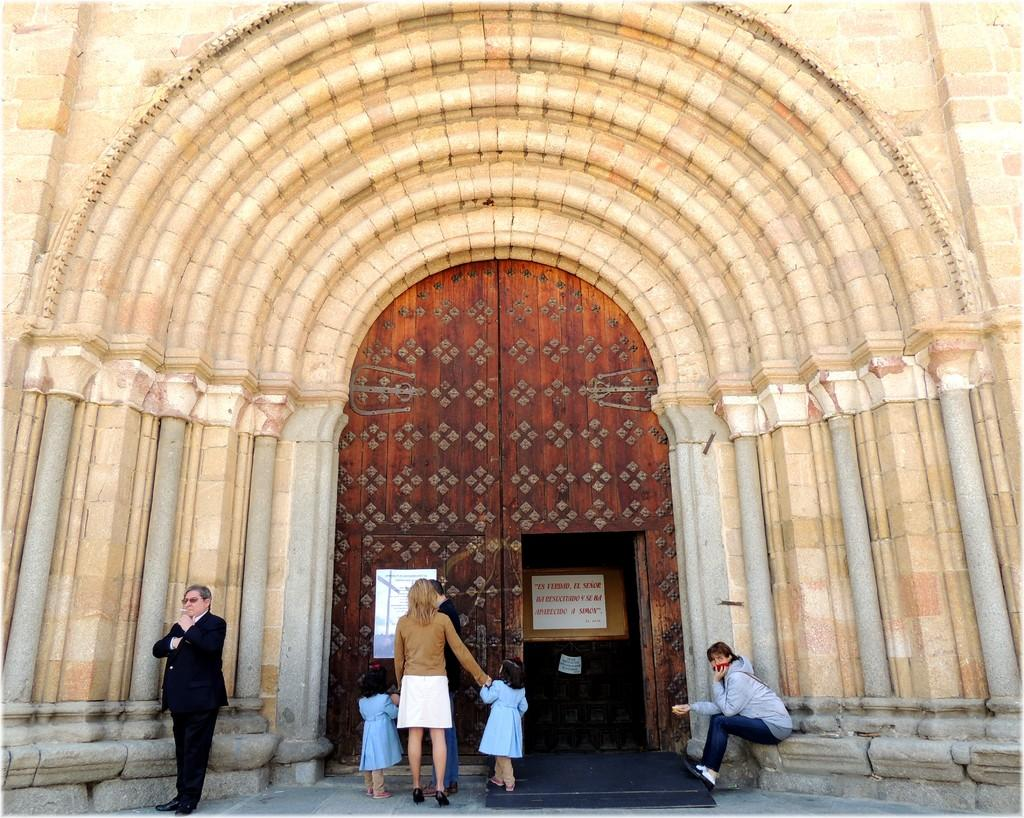What are the people in the image doing? The people in the image are standing. Is there anyone sitting in the image? Yes, there is a person sitting in the image. What is in front of the people? There is a wall in front of the people. What can be seen on the wall? There is a big wooden door on the wall. What is on the door? There is a poster on the door. What type of yoke is being used by the people in the image? There is no yoke present in the image. What message does the poster on the door convey about peace? The image does not provide any information about the content of the poster, so we cannot determine if it conveys a message about peace. 